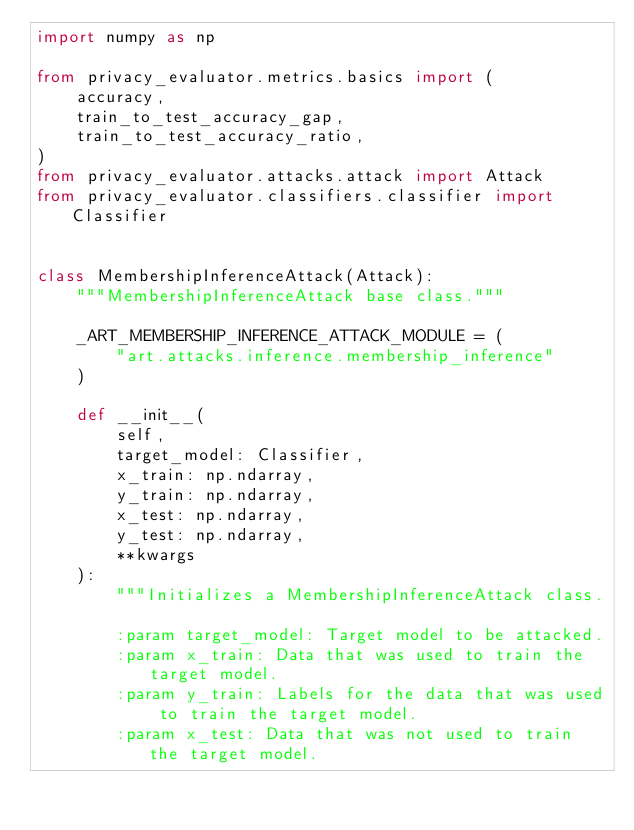<code> <loc_0><loc_0><loc_500><loc_500><_Python_>import numpy as np

from privacy_evaluator.metrics.basics import (
    accuracy,
    train_to_test_accuracy_gap,
    train_to_test_accuracy_ratio,
)
from privacy_evaluator.attacks.attack import Attack
from privacy_evaluator.classifiers.classifier import Classifier


class MembershipInferenceAttack(Attack):
    """MembershipInferenceAttack base class."""

    _ART_MEMBERSHIP_INFERENCE_ATTACK_MODULE = (
        "art.attacks.inference.membership_inference"
    )

    def __init__(
        self,
        target_model: Classifier,
        x_train: np.ndarray,
        y_train: np.ndarray,
        x_test: np.ndarray,
        y_test: np.ndarray,
        **kwargs
    ):
        """Initializes a MembershipInferenceAttack class.

        :param target_model: Target model to be attacked.
        :param x_train: Data that was used to train the target model.
        :param y_train: Labels for the data that was used to train the target model.
        :param x_test: Data that was not used to train the target model.</code> 